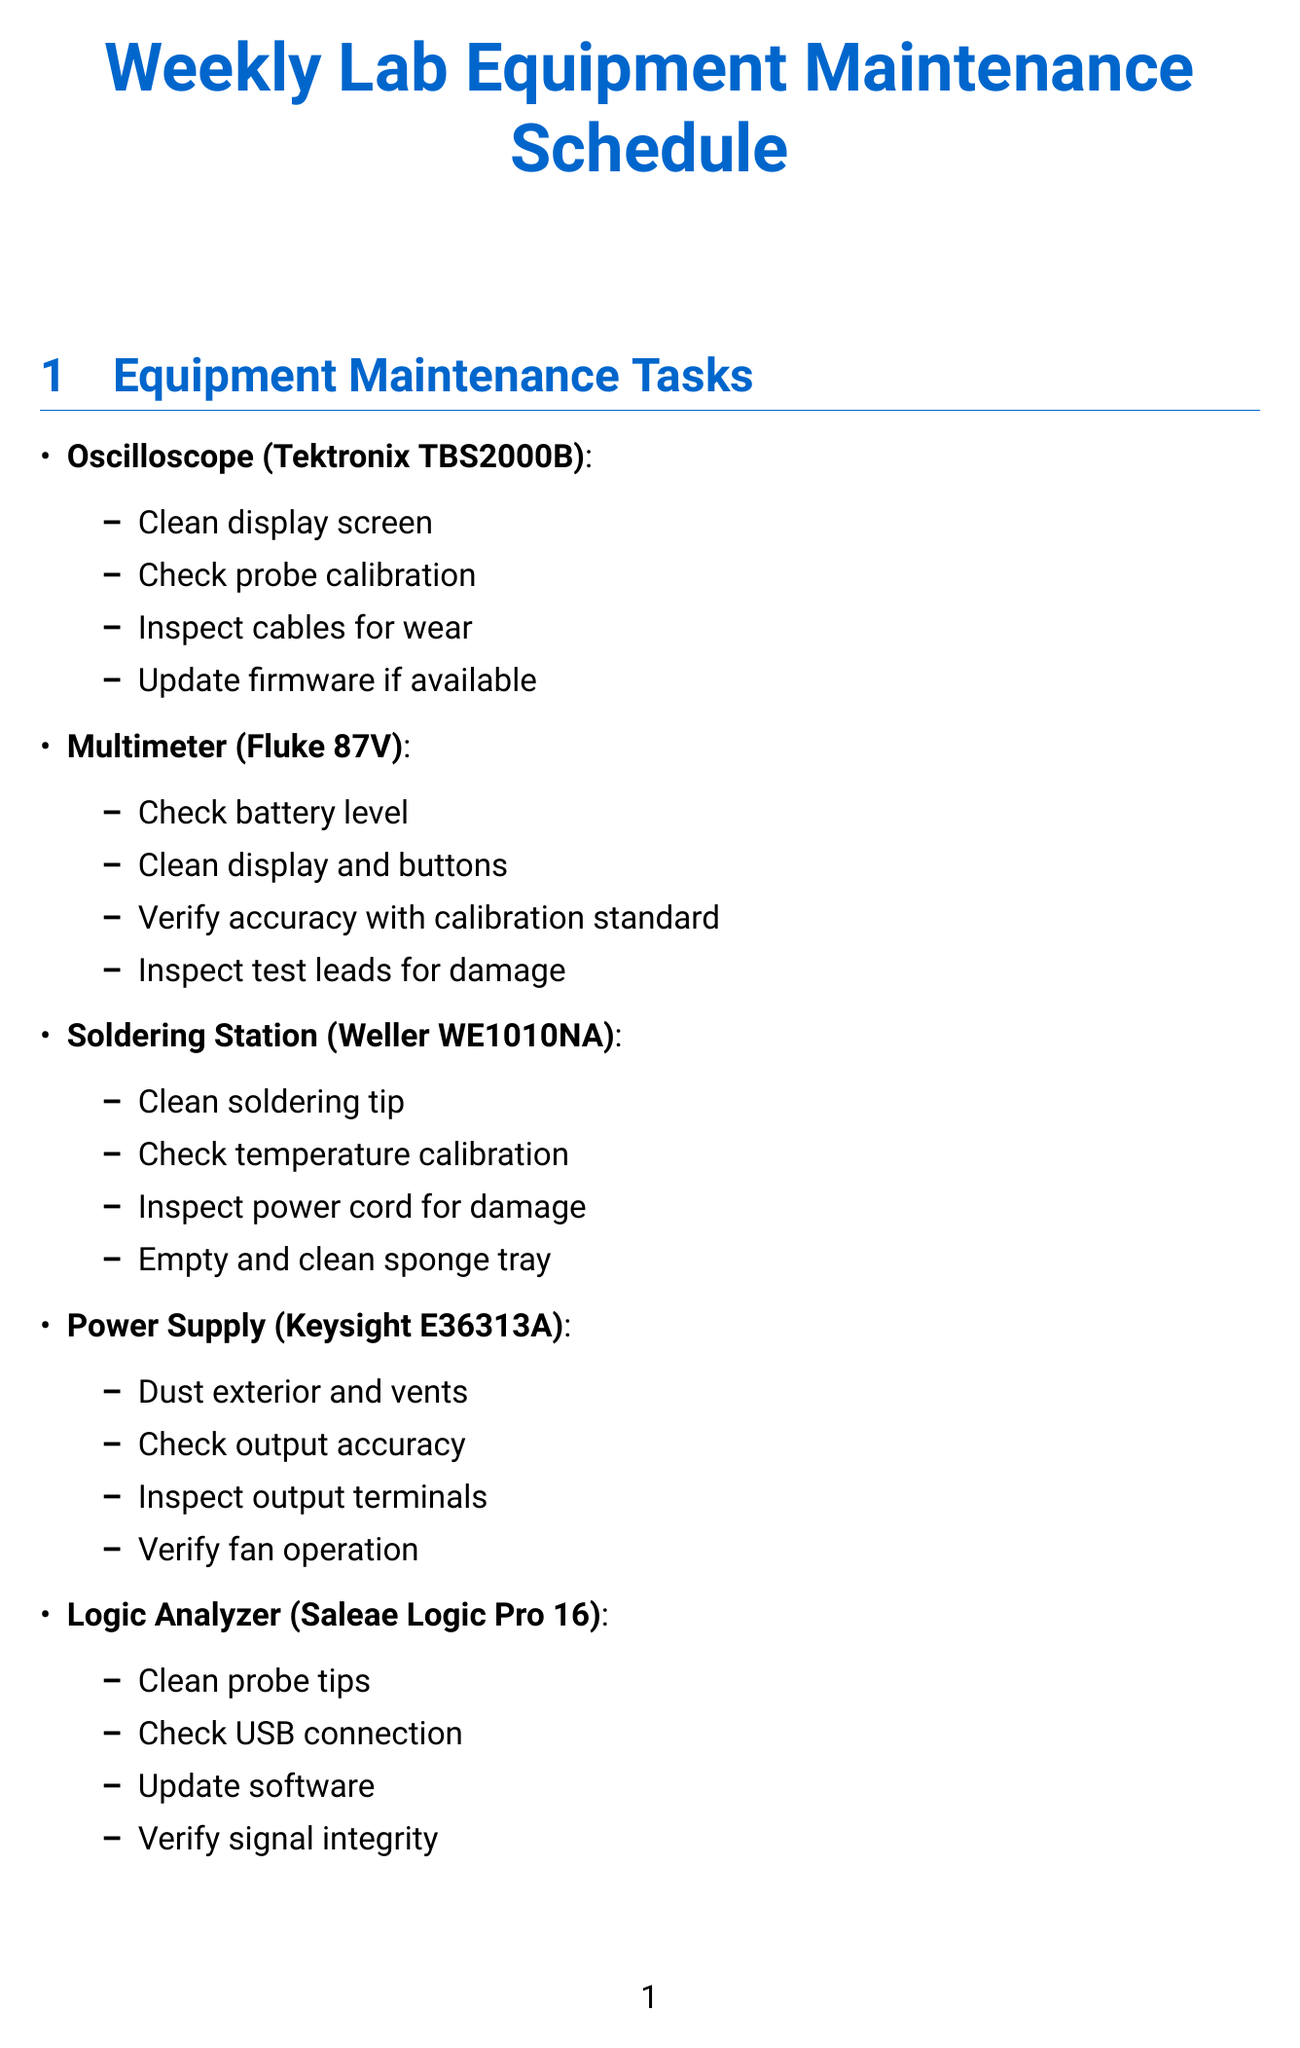What maintenance task is assigned to the Oscilloscope? The maintenance tasks for the Oscilloscope include cleaning the display screen, checking probe calibration, inspecting cables for wear, and updating firmware if available.
Answer: Clean display screen Who is responsible for Soldering station maintenance? Emily Chen is assigned the responsibility for Soldering station maintenance as mentioned in the assigned personnel section.
Answer: Emily Chen What model is the Multimeter? The document specifies the model of the Multimeter as Fluke 87V.
Answer: Fluke 87V How often is equipment maintenance scheduled? The document states that equipment maintenance is scheduled on a weekly basis across multiple sections.
Answer: Weekly What should be done before cleaning the Power Supply? The safety protocols specify that power should be disconnected from mains before cleaning the Power Supply.
Answer: Disconnect from mains What is the role of Michael Johnson? Michael Johnson's role is identified as Junior Electrical Engineer in the assigned personnel section.
Answer: Junior Electrical Engineer What are the general safety protocols about food and drinks? The document mentions that food and drinks should be kept away from work areas as part of the general safety protocols.
Answer: Keep food and drinks away from work areas Which piece of equipment requires temperature calibration? The Soldering Station is the equipment that requires checking temperature calibration as one of its maintenance tasks.
Answer: Soldering Station 